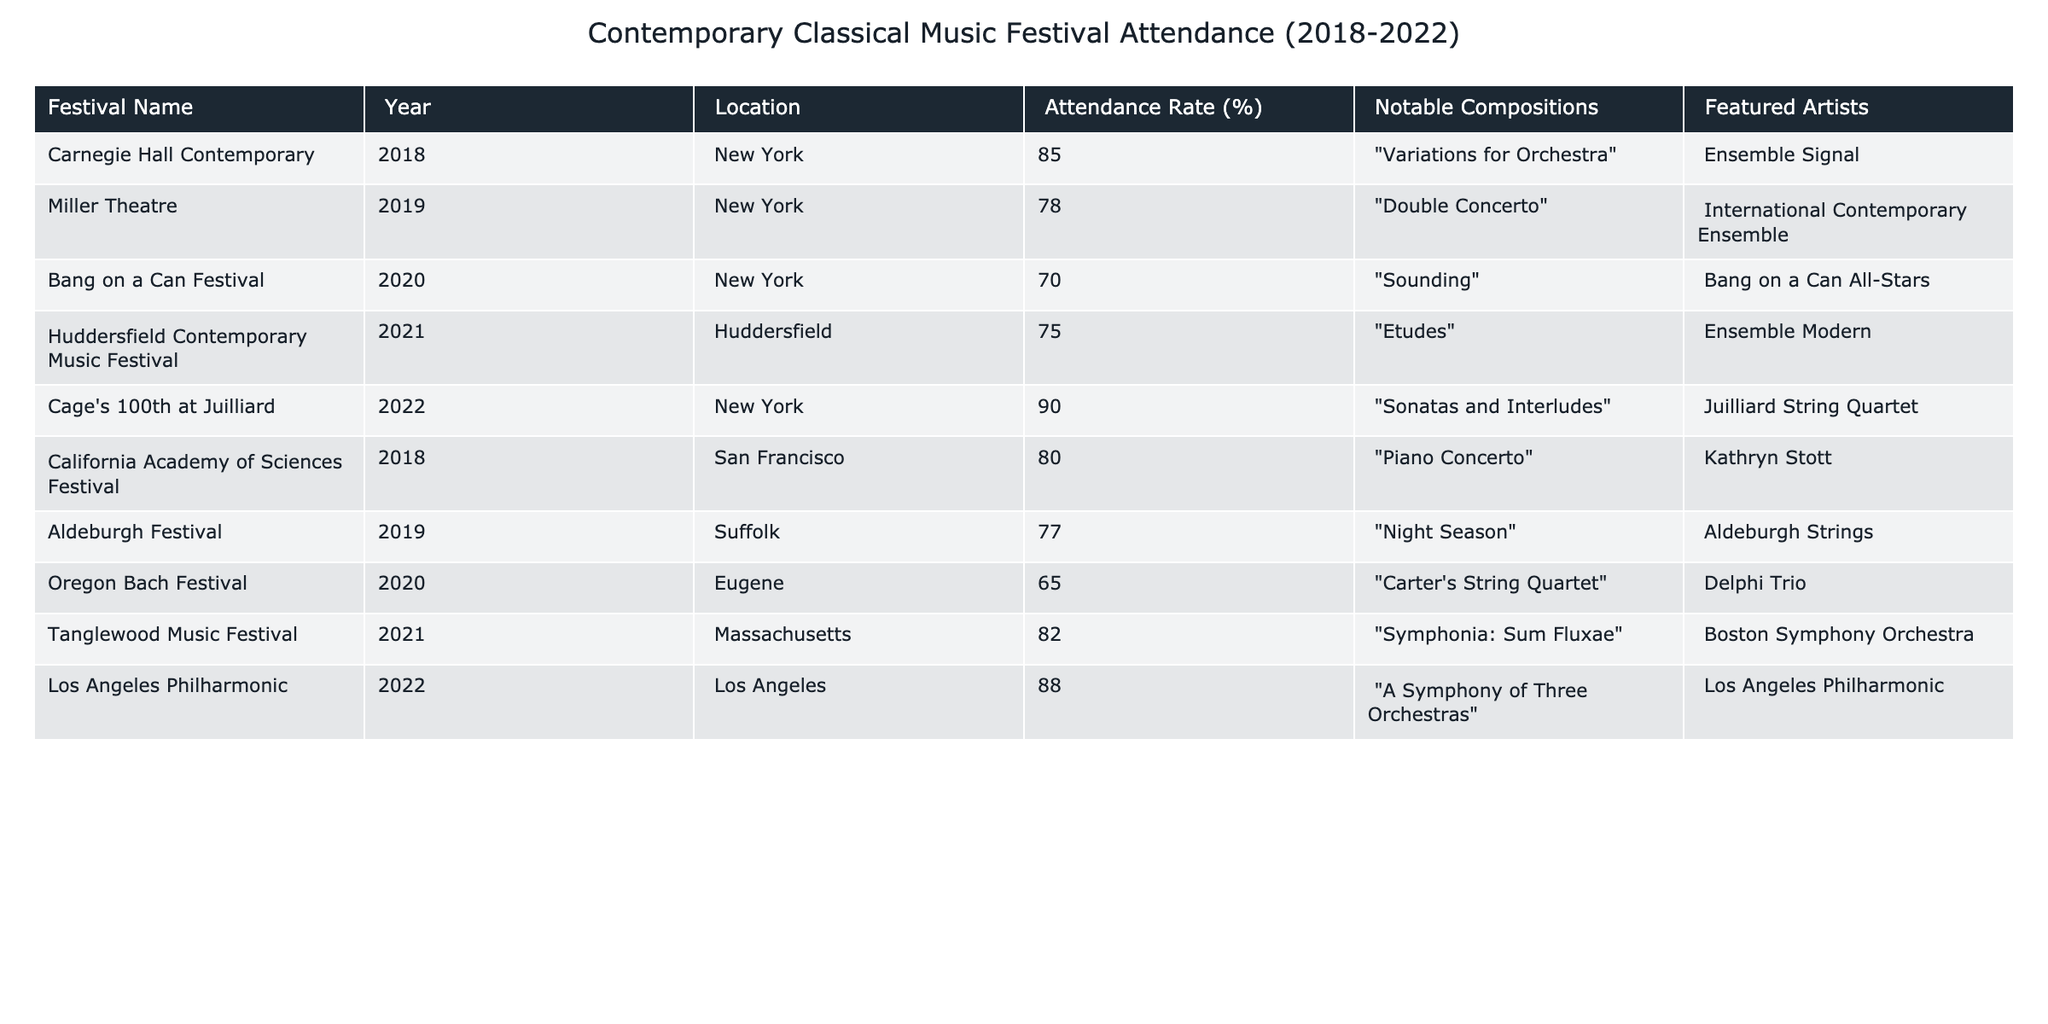What was the highest attendance rate recorded among the festivals? The table lists the attendance rates, and the highest rate is 90% for the festival "Cage's 100th at Juilliard" in 2022.
Answer: 90% Which festival had the lowest attendance rate? By examining the table, the lowest attendance rate is 65%, which corresponds to the "Oregon Bach Festival" in 2020.
Answer: 65% How many festivals were held in New York? The table shows three festivals located in New York: "Carnegie Hall Contemporary" in 2018, "Miller Theatre" in 2019, and "Cage's 100th at Juilliard" in 2022, totaling three.
Answer: 3 What was the average attendance rate for the festivals between 2018 and 2022? The attendance rates for the festivals are 85, 78, 70, 75, 90, 80, 77, 65, 82, and 88. Summing these gives  85 + 78 + 70 + 75 + 90 + 80 + 77 + 65 + 82 + 88 =  815. There are 10 festivals, so the average is 815 / 10 = 81.5.
Answer: 81.5% Did the attendance rate in 2021 improve compared to 2020? In 2020, the attendance rate for the "Bang on a Can Festival" was 70%, and in 2021 for the "Huddersfield Contemporary Music Festival," it was 75%. Since 75% is greater than 70%, there was an improvement from 2020 to 2021.
Answer: Yes Which festival featured the "Piano Concerto"? The "Piano Concerto" was performed at the "California Academy of Sciences Festival" in 2018, as indicated in the table.
Answer: California Academy of Sciences Festival What was the difference in attendance rates between the highest and lowest attended festivals? The table shows the highest attendance rate at 90% and the lowest at 65%. The difference is 90 - 65 = 25%.
Answer: 25% How many festivals featured notable compositions by Elliott Carter? The "Oregon Bach Festival" in 2020 featured "Carter's String Quartet," which indicates that one festival included a notable work by Elliott Carter.
Answer: 1 Which year had the highest average attendance rate across all festivals? To find this, we calculate the average attendance rate for each year: 2018: (85 + 80) / 2 = 82.5; 2019: (78 + 77) / 2 = 77.5; 2020: (70 + 65) / 2 = 67.5; 2021: (75 + 82) / 2 = 78.5; 2022: (90 + 88) / 2 = 89. The highest average is for 2022 at 89.
Answer: 2022 